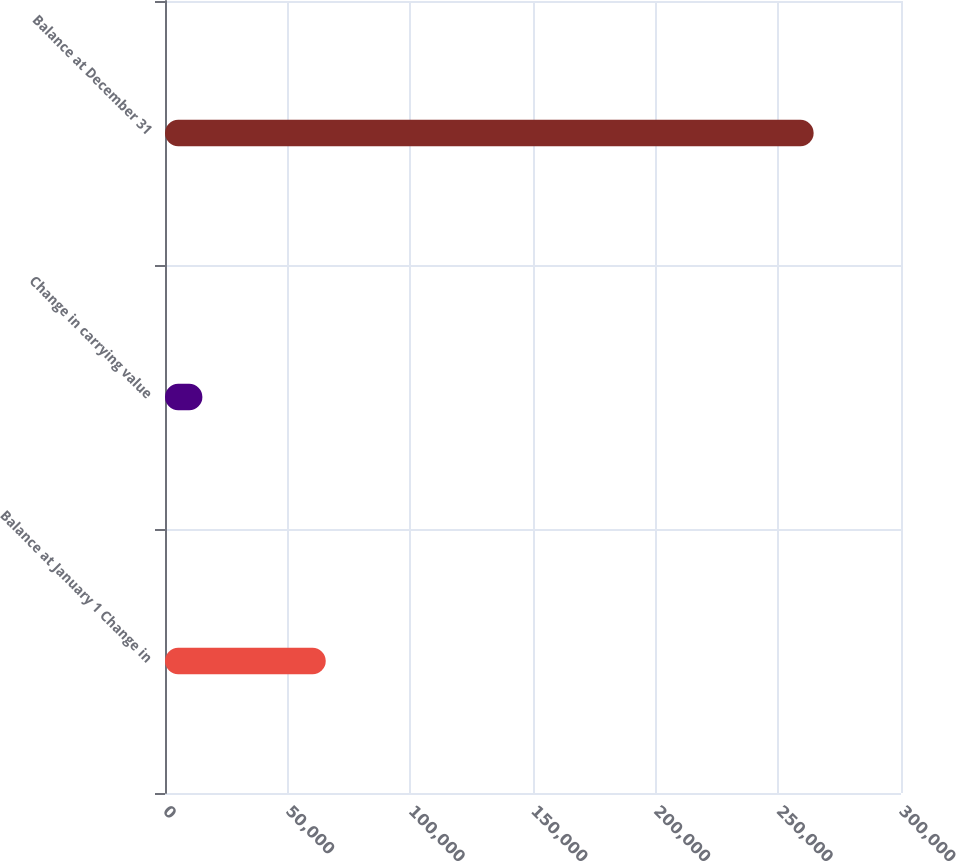Convert chart. <chart><loc_0><loc_0><loc_500><loc_500><bar_chart><fcel>Balance at January 1 Change in<fcel>Change in carrying value<fcel>Balance at December 31<nl><fcel>65524<fcel>15247<fcel>264394<nl></chart> 